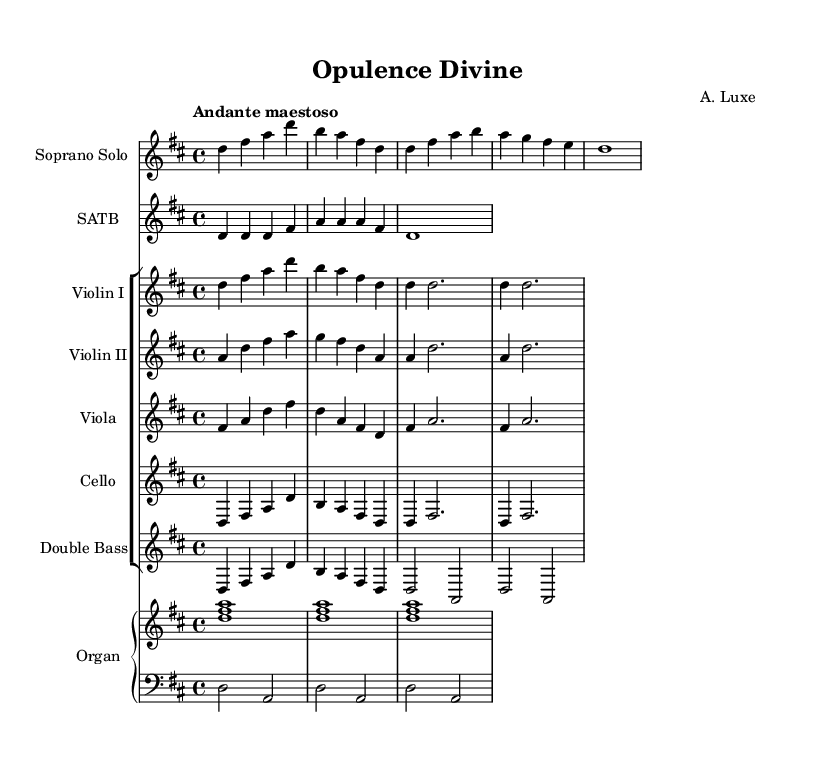What is the key signature of this music? The key signature is indicated at the beginning of the score. Looking at the sheet music, there are two sharps, which denotes the key of D major.
Answer: D major What is the time signature of this piece? The time signature is displayed on the staff at the beginning of the music. In this case, it shows 4/4, indicating four beats per measure.
Answer: 4/4 What is the tempo marking of this music? The tempo marking is also provided in the score, right at the beginning. It reads "Andante maestoso", which sets the speed and character of the piece.
Answer: Andante maestoso How many measures are in the soprano solo segment? By counting the individual segments separated by the bar lines in the soprano solo, we find there are a total of four measures.
Answer: 4 What is the main motif for the violins? Analyzing the violin parts, we see that the main motif is repeated in the composition. The section with "d4 d2." suggests this motif occurs multiple times.
Answer: d What type of vocal arrangement does this piece feature? Examining the score structure, we observe a choir part is included, specifically labeled as "SATB," which stands for Soprano, Alto, Tenor, and Bass.
Answer: SATB Which instrument is providing the bass line? Looking at the instrumentation, both the cello and double bass parts are indicated for the bass line. However, the cello is written as the first bass line part, providing the primary foundation.
Answer: Cello 